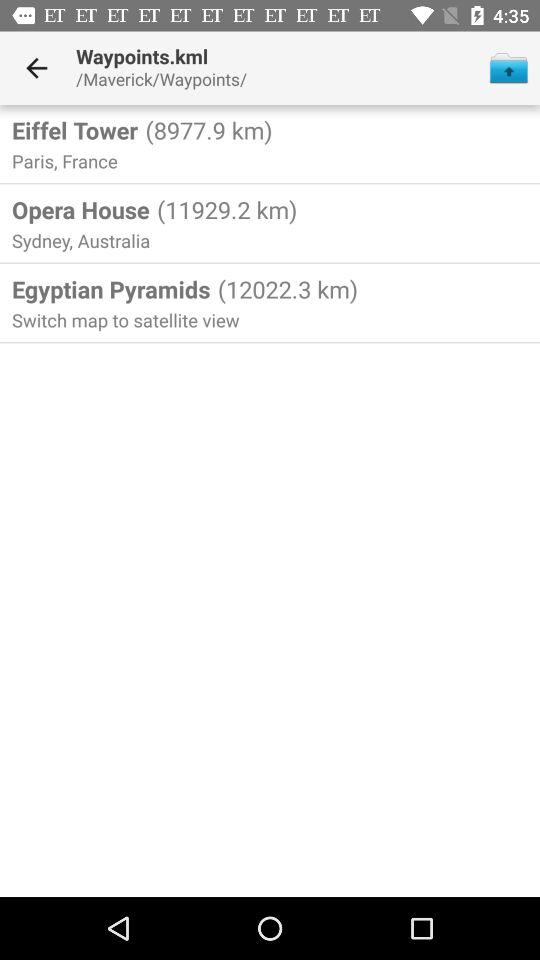Which waypoint is located the farthest from the current location?
Answer the question using a single word or phrase. Egyptian Pyramids 